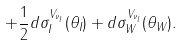Convert formula to latex. <formula><loc_0><loc_0><loc_500><loc_500>+ \frac { 1 } { 2 } d \sigma _ { I } ^ { V _ { \nu _ { l } } } ( \theta _ { I } ) + d \sigma _ { W } ^ { V _ { \nu _ { l } } } ( \theta _ { W } ) .</formula> 